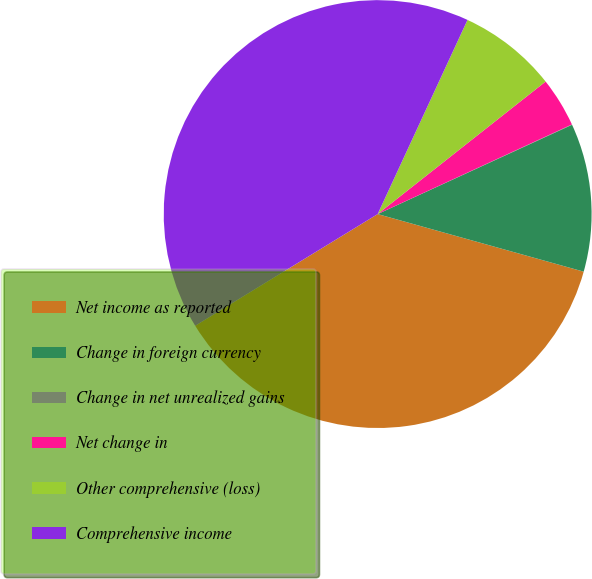Convert chart. <chart><loc_0><loc_0><loc_500><loc_500><pie_chart><fcel>Net income as reported<fcel>Change in foreign currency<fcel>Change in net unrealized gains<fcel>Net change in<fcel>Other comprehensive (loss)<fcel>Comprehensive income<nl><fcel>36.92%<fcel>11.19%<fcel>0.03%<fcel>3.75%<fcel>7.47%<fcel>40.64%<nl></chart> 